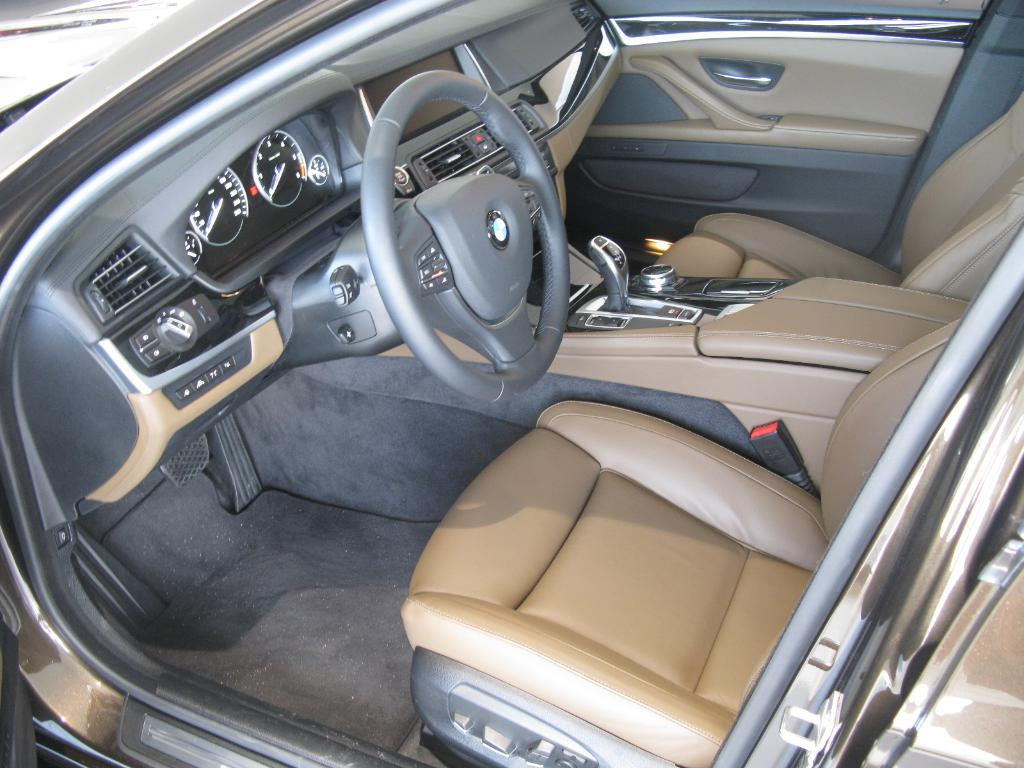What is the focus of the image? The image is a zoomed-in view of the inside of a car. Can you describe the perspective of the image? The image provides a detailed view of the interior of the car. What is the value of the car in the image? The value of the car cannot be determined from the image, as it only shows the interior view. 